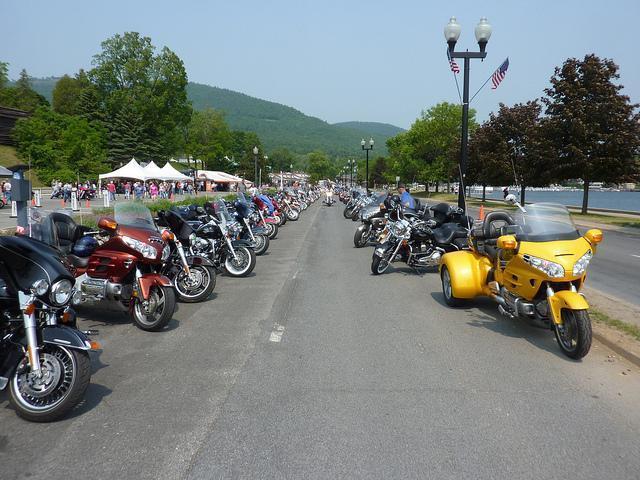How many wheels does the yellow bike have?
Give a very brief answer. 3. How many motorcycles are there?
Give a very brief answer. 7. How many birds are in the water?
Give a very brief answer. 0. 